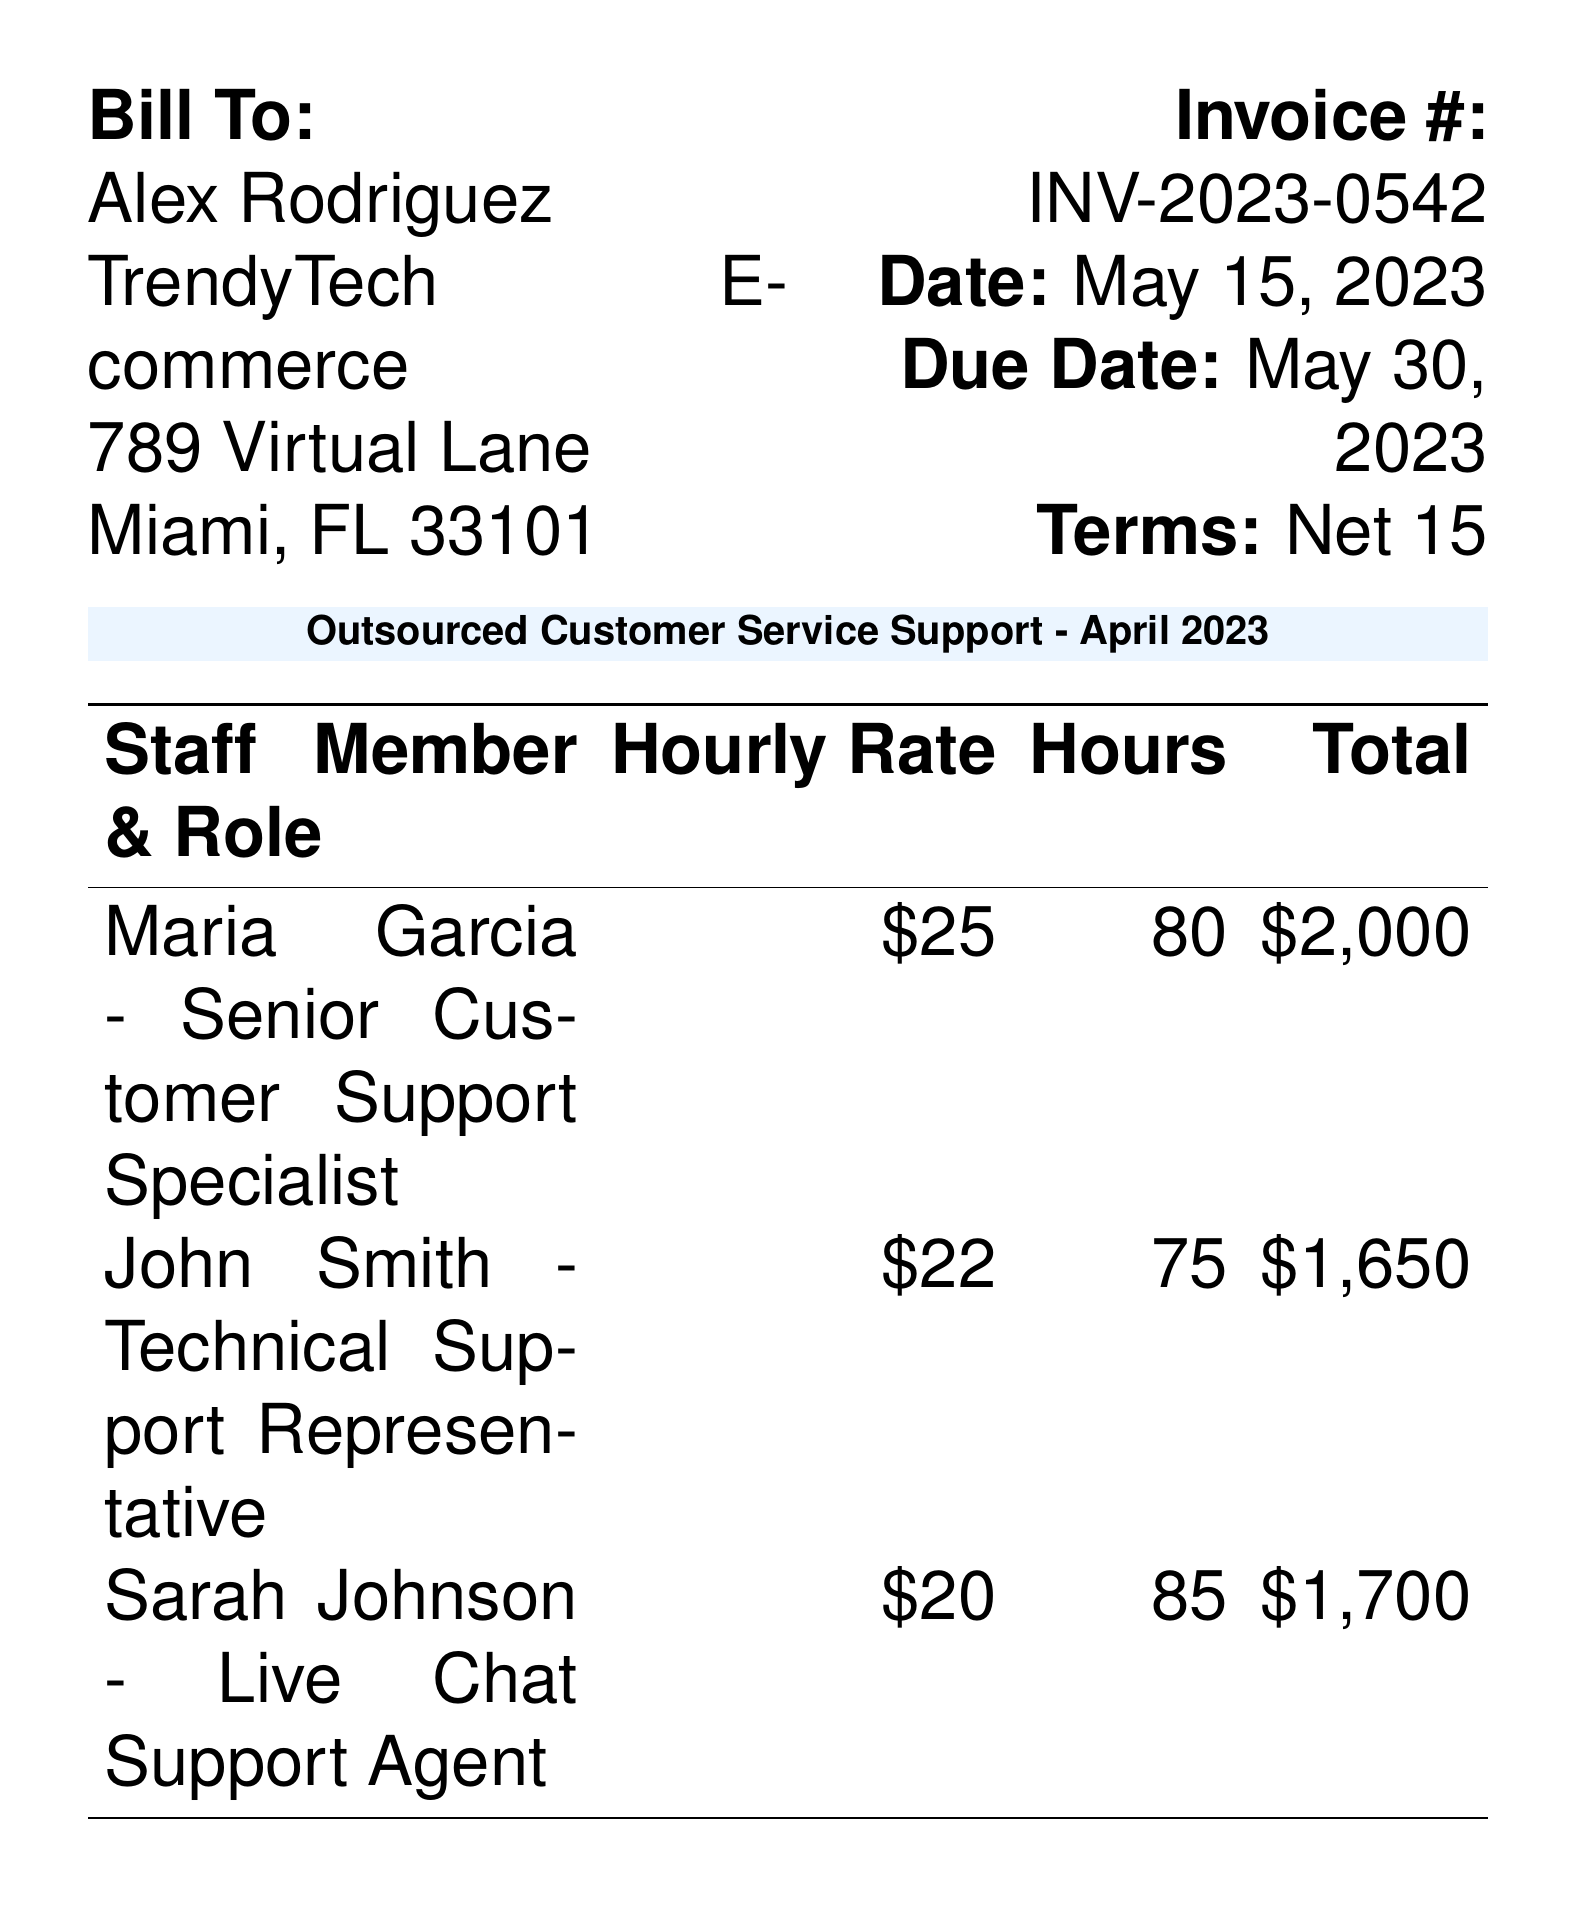what is the invoice number? The invoice number is listed prominently in the document, specifically in the header section.
Answer: INV-2023-0542 who is the bill to? The document lists the recipient of the bill under the "Bill To" section.
Answer: Alex Rodriguez what is the total due amount? The total due amount is calculated at the end of the document and represents the sum of all charges including tax.
Answer: $6,037.20 how many hours did Maria Garcia work? The hours worked by each staff member are detailed in the table within the document.
Answer: 80 what is the hourly rate for the Technical Support Representative? The hourly rate for each staff member is specified in the corresponding column in the table.
Answer: $22 what payment methods are accepted? The document includes a section that lists the accepted payment methods.
Answer: Bank Transfer, Credit Card, PayPal how much was charged for tax? The tax amount is presented in the summary section, detailing additional charges.
Answer: $447.20 what was the total hours worked by Sarah Johnson? The document provides the number of hours worked by each staff member in the performance table.
Answer: 85 what role did John Smith serve? The roles of the staff members are identified alongside their names in the table.
Answer: Technical Support Representative 